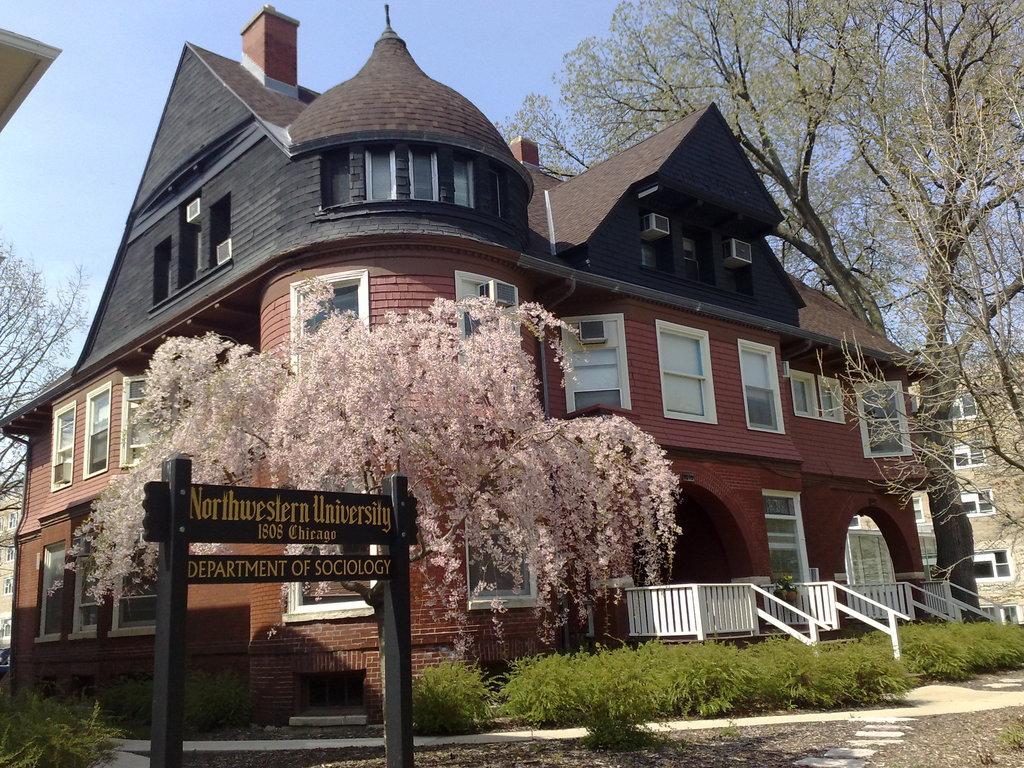Can you describe this image briefly? There is a board and plants are present at the bottom of this image. We can see trees and a building in the middle of this image. The sky is in the background. 